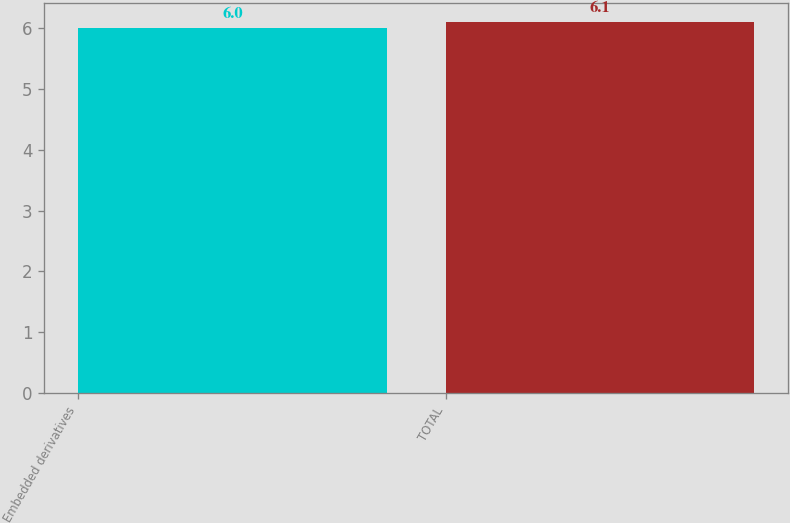<chart> <loc_0><loc_0><loc_500><loc_500><bar_chart><fcel>Embedded derivatives<fcel>TOTAL<nl><fcel>6<fcel>6.1<nl></chart> 